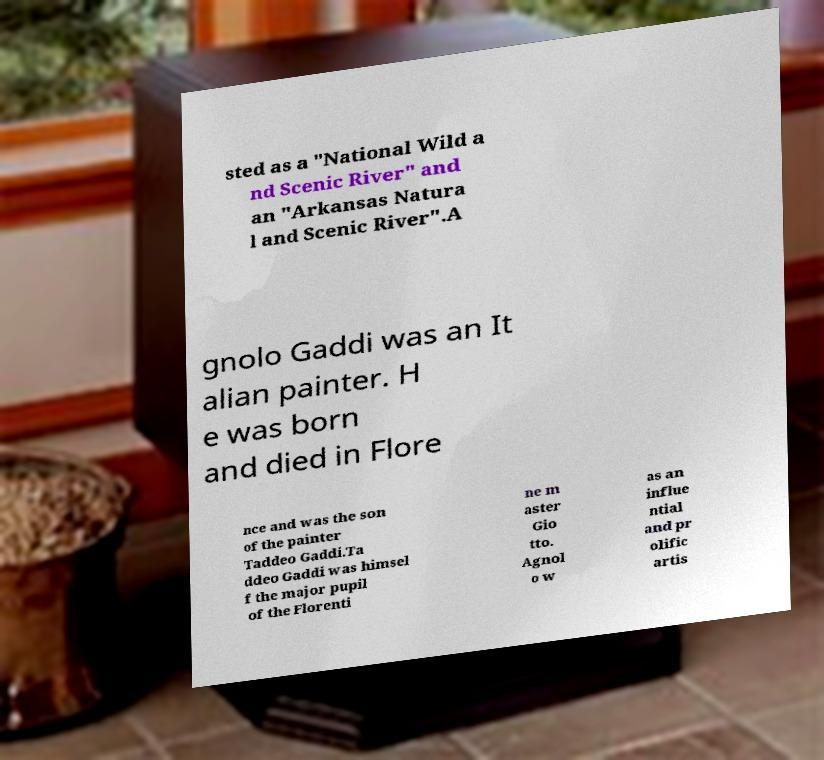I need the written content from this picture converted into text. Can you do that? sted as a "National Wild a nd Scenic River" and an "Arkansas Natura l and Scenic River".A gnolo Gaddi was an It alian painter. H e was born and died in Flore nce and was the son of the painter Taddeo Gaddi.Ta ddeo Gaddi was himsel f the major pupil of the Florenti ne m aster Gio tto. Agnol o w as an influe ntial and pr olific artis 